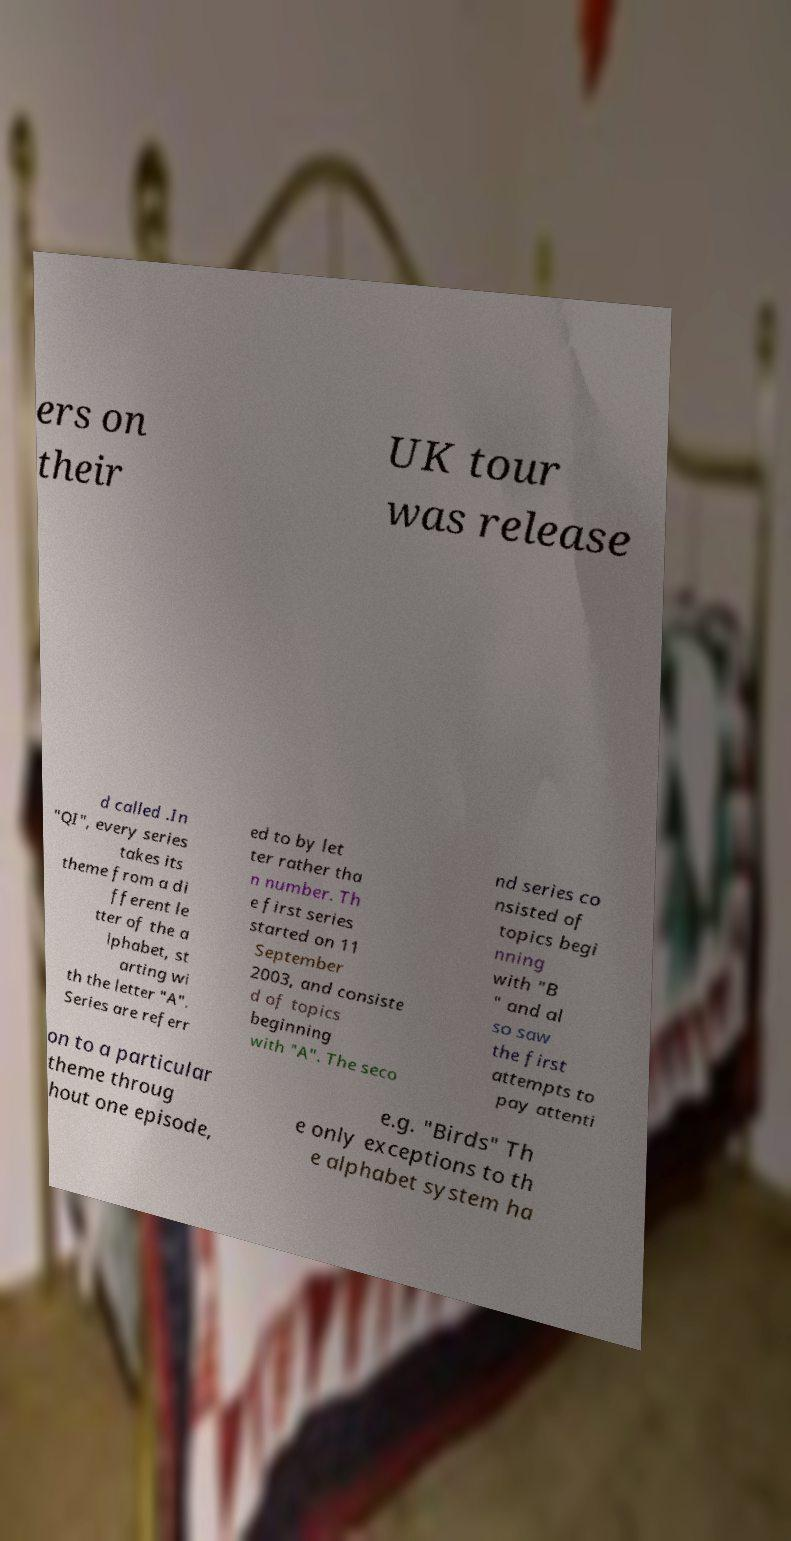For documentation purposes, I need the text within this image transcribed. Could you provide that? ers on their UK tour was release d called .In "QI", every series takes its theme from a di fferent le tter of the a lphabet, st arting wi th the letter "A". Series are referr ed to by let ter rather tha n number. Th e first series started on 11 September 2003, and consiste d of topics beginning with "A". The seco nd series co nsisted of topics begi nning with "B " and al so saw the first attempts to pay attenti on to a particular theme throug hout one episode, e.g. "Birds" Th e only exceptions to th e alphabet system ha 